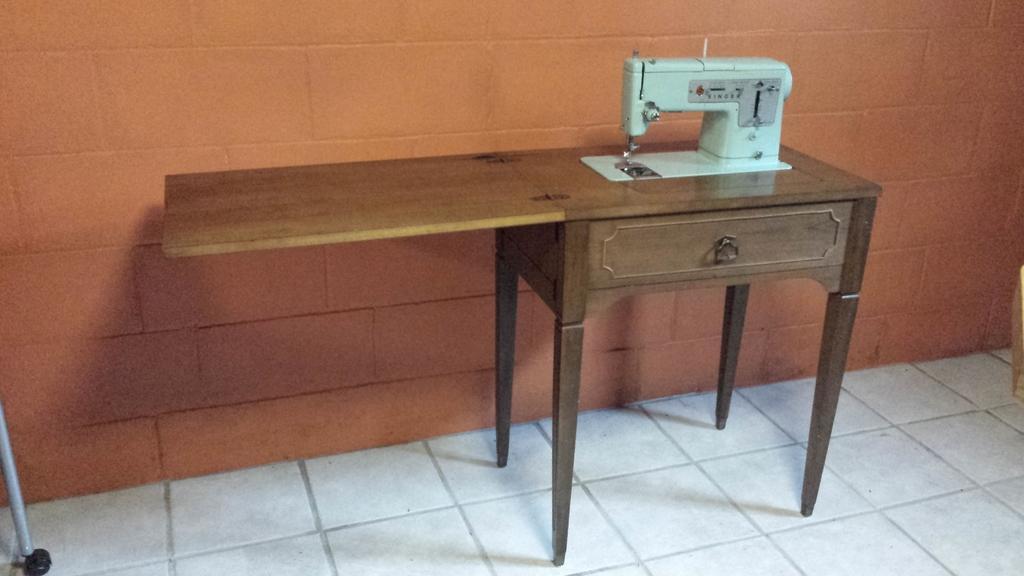How would you summarize this image in a sentence or two? In this picture we can observe a stitching machine which is in white color on the brown color table. We can observe a desk. This table is placed on the white color floor. In the background there is a wall. 